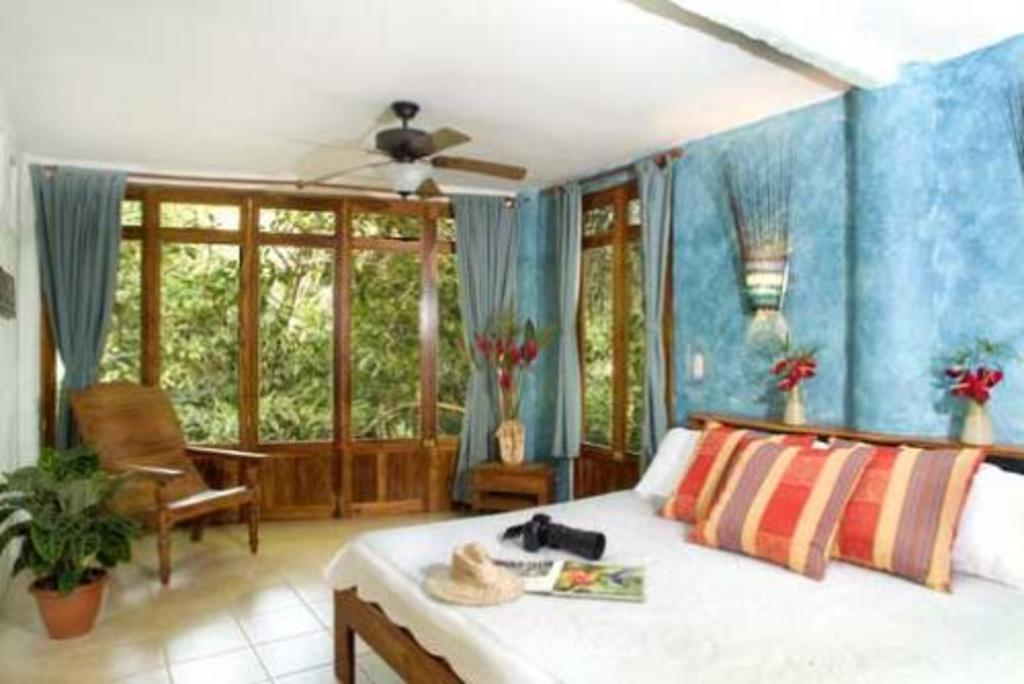Where is the setting of the image? The image is inside a room. What furniture is present in the room? There is a bed with pillows, a chair, and a camera in the room. What accessories can be seen in the room? There is a hat, a book, and flower pots in the room. What type of window is present in the room? There are glass windows in the room. What is used for ventilation in the room? There is a ceiling fan in the room. How does the ticket help the person in the image? There is no ticket present in the image, so it cannot help anyone in the image. 